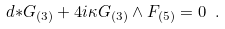Convert formula to latex. <formula><loc_0><loc_0><loc_500><loc_500>d { * } G _ { ( 3 ) } + 4 i \kappa G _ { ( 3 ) } \wedge F _ { ( 5 ) } = 0 \ .</formula> 